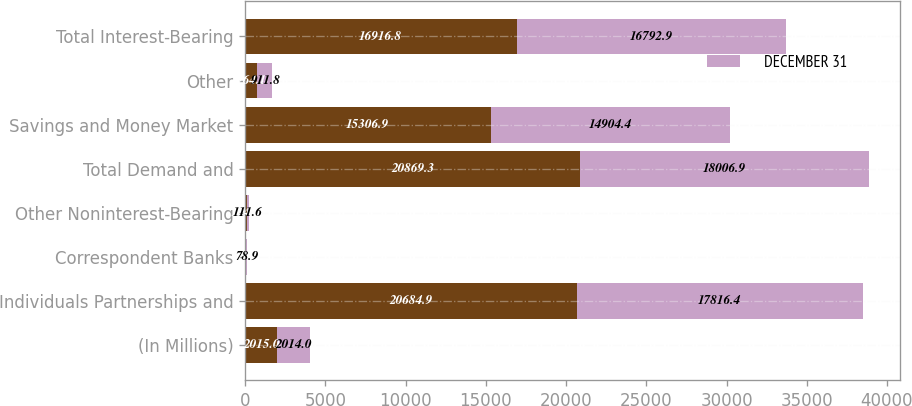Convert chart to OTSL. <chart><loc_0><loc_0><loc_500><loc_500><stacked_bar_chart><ecel><fcel>(In Millions)<fcel>Individuals Partnerships and<fcel>Correspondent Banks<fcel>Other Noninterest-Bearing<fcel>Total Demand and<fcel>Savings and Money Market<fcel>Other<fcel>Total Interest-Bearing<nl><fcel>nan<fcel>2015<fcel>20684.9<fcel>59.8<fcel>124.6<fcel>20869.3<fcel>15306.9<fcel>764.1<fcel>16916.8<nl><fcel>DECEMBER 31<fcel>2014<fcel>17816.4<fcel>78.9<fcel>111.6<fcel>18006.9<fcel>14904.4<fcel>911.8<fcel>16792.9<nl></chart> 